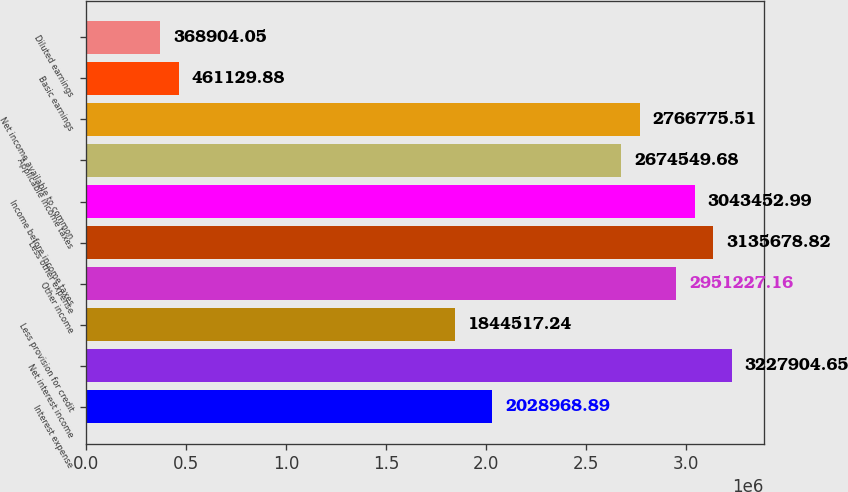<chart> <loc_0><loc_0><loc_500><loc_500><bar_chart><fcel>Interest expense<fcel>Net interest income<fcel>Less provision for credit<fcel>Other income<fcel>Less other expense<fcel>Income before income taxes<fcel>Applicable income taxes<fcel>Net income available to common<fcel>Basic earnings<fcel>Diluted earnings<nl><fcel>2.02897e+06<fcel>3.2279e+06<fcel>1.84452e+06<fcel>2.95123e+06<fcel>3.13568e+06<fcel>3.04345e+06<fcel>2.67455e+06<fcel>2.76678e+06<fcel>461130<fcel>368904<nl></chart> 